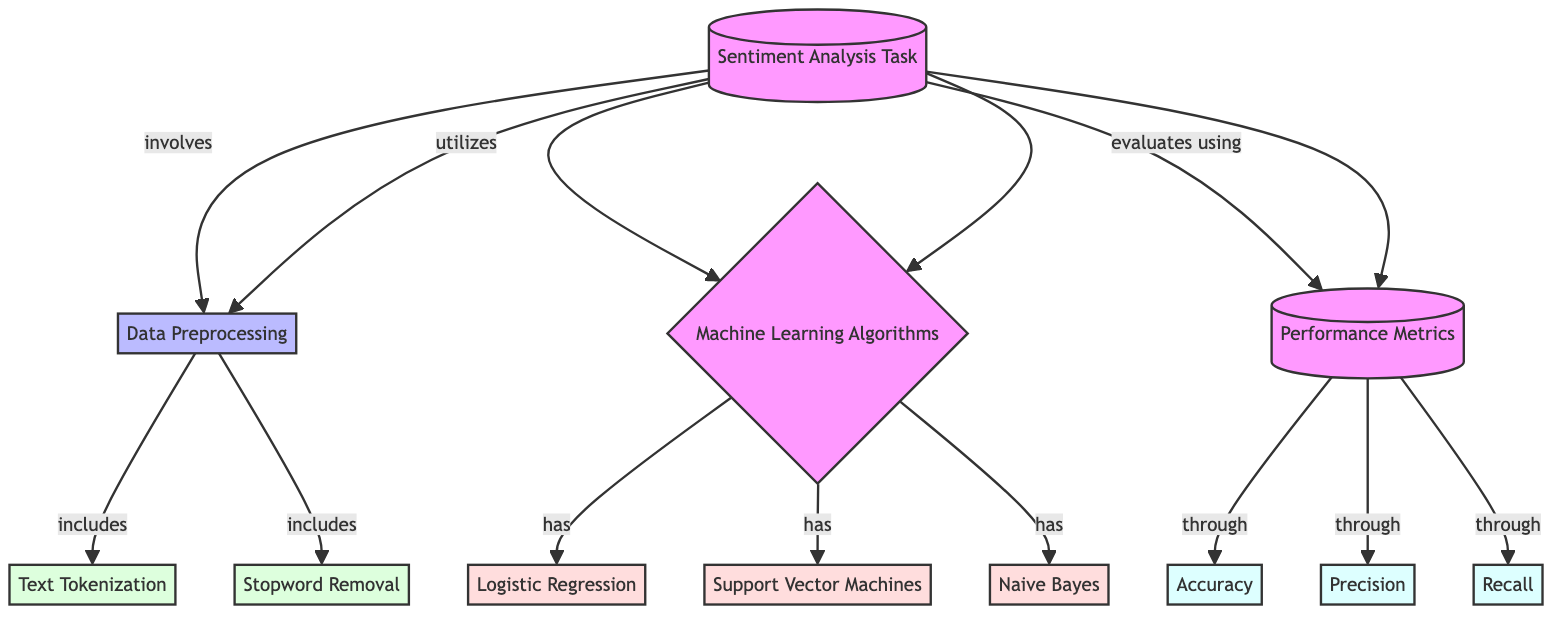What is the main task shown in the diagram? The diagram identifies the main task at the top, which is labeled "Sentiment Analysis Task." This provides the overall focus of the diagram.
Answer: Sentiment Analysis Task How many machine learning algorithms are presented? The diagram outlines three specific machine learning algorithms listed under the node "Machine Learning Algorithms," which are Logistic Regression, Support Vector Machines, and Naive Bayes. Therefore, there are three algorithms in total.
Answer: 3 What are the three performance metrics evaluated in the analysis? The diagram presents the performance metrics evaluated specifically as Accuracy, Precision, and Recall, which are all connected to the node "Performance Metrics."
Answer: Accuracy, Precision, Recall What is the first step in the data preprocessing? The first step in the data preprocessing phase, as indicated by the flow from "Data Preprocessing," is "Text Tokenization." This step occurs after the sentiment analysis task is initiated.
Answer: Text Tokenization What relationship exists between "Sentiment Analysis Task" and "Performance Metrics"? The diagram illustrates that the "Sentiment Analysis Task" evaluates the output based on the "Performance Metrics." The connection shows that the analysis of performance metrics follows the completion of the task.
Answer: evaluates using What type of processing is illustrated between "Data Preprocessing" and its sub-nodes? The diagram categorizes "Data Preprocessing" as a process that includes steps such as Text Tokenization and Stopword Removal, indicating that these activities are part of the data preparation stage.
Answer: process Which algorithm is linked directly to the node "Machine Learning Algorithms"? The diagram connects three specific algorithms to the node "Machine Learning Algorithms": Logistic Regression, Support Vector Machines, and Naive Bayes. Each of these algorithms branches off from the main node.
Answer: Logistic Regression, Support Vector Machines, Naive Bayes What does the node "Performance Metrics" include besides accuracy? The "Performance Metrics" node comprises additional metrics apart from accuracy, specifically mentioning Precision and Recall. These metrics provide insight into different dimensions of model performance in sentiment analysis.
Answer: Precision, Recall 